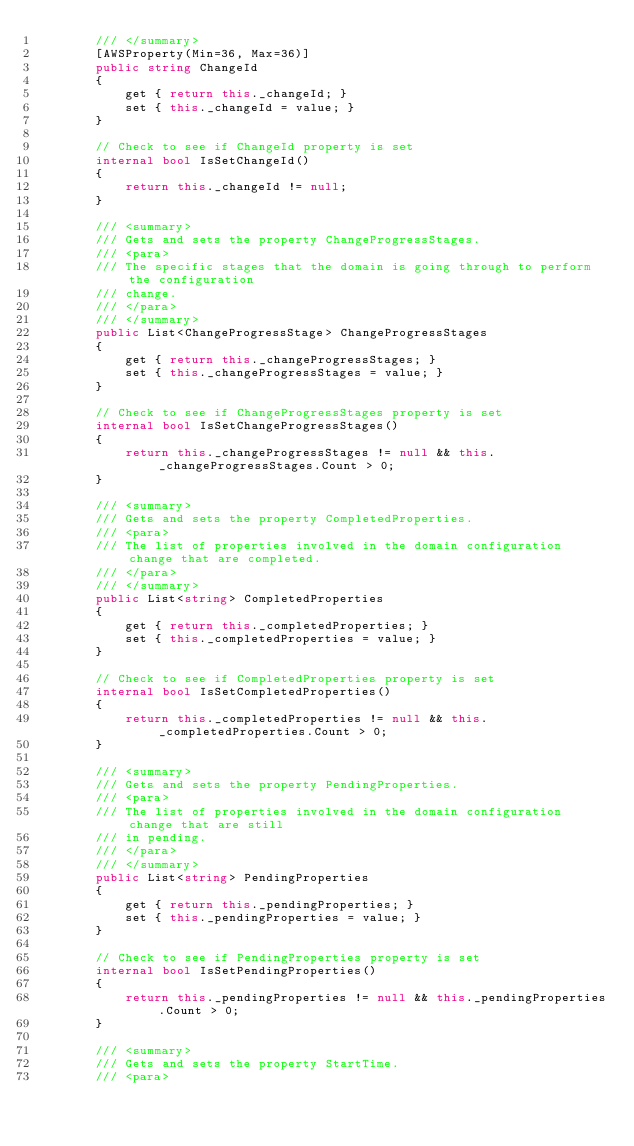<code> <loc_0><loc_0><loc_500><loc_500><_C#_>        /// </summary>
        [AWSProperty(Min=36, Max=36)]
        public string ChangeId
        {
            get { return this._changeId; }
            set { this._changeId = value; }
        }

        // Check to see if ChangeId property is set
        internal bool IsSetChangeId()
        {
            return this._changeId != null;
        }

        /// <summary>
        /// Gets and sets the property ChangeProgressStages. 
        /// <para>
        /// The specific stages that the domain is going through to perform the configuration
        /// change.
        /// </para>
        /// </summary>
        public List<ChangeProgressStage> ChangeProgressStages
        {
            get { return this._changeProgressStages; }
            set { this._changeProgressStages = value; }
        }

        // Check to see if ChangeProgressStages property is set
        internal bool IsSetChangeProgressStages()
        {
            return this._changeProgressStages != null && this._changeProgressStages.Count > 0; 
        }

        /// <summary>
        /// Gets and sets the property CompletedProperties. 
        /// <para>
        /// The list of properties involved in the domain configuration change that are completed.
        /// </para>
        /// </summary>
        public List<string> CompletedProperties
        {
            get { return this._completedProperties; }
            set { this._completedProperties = value; }
        }

        // Check to see if CompletedProperties property is set
        internal bool IsSetCompletedProperties()
        {
            return this._completedProperties != null && this._completedProperties.Count > 0; 
        }

        /// <summary>
        /// Gets and sets the property PendingProperties. 
        /// <para>
        /// The list of properties involved in the domain configuration change that are still
        /// in pending.
        /// </para>
        /// </summary>
        public List<string> PendingProperties
        {
            get { return this._pendingProperties; }
            set { this._pendingProperties = value; }
        }

        // Check to see if PendingProperties property is set
        internal bool IsSetPendingProperties()
        {
            return this._pendingProperties != null && this._pendingProperties.Count > 0; 
        }

        /// <summary>
        /// Gets and sets the property StartTime. 
        /// <para></code> 